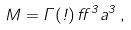Convert formula to latex. <formula><loc_0><loc_0><loc_500><loc_500>M = \Gamma ( \omega ) \, \alpha ^ { 3 } a ^ { 3 } \, ,</formula> 